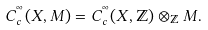<formula> <loc_0><loc_0><loc_500><loc_500>C _ { c } ^ { ^ { \infty } } ( X , M ) = C _ { c } ^ { ^ { \infty } } ( X , { \mathbb { Z } } ) \otimes _ { \mathbb { Z } } M .</formula> 